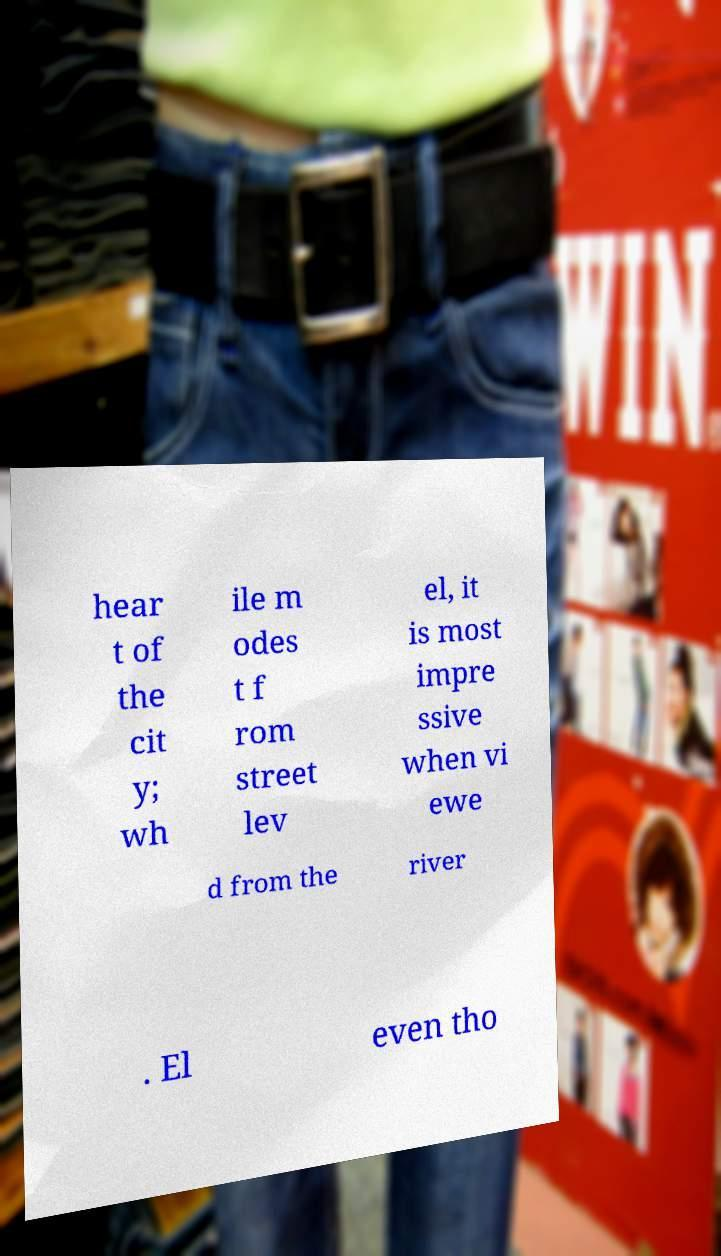For documentation purposes, I need the text within this image transcribed. Could you provide that? hear t of the cit y; wh ile m odes t f rom street lev el, it is most impre ssive when vi ewe d from the river . El even tho 